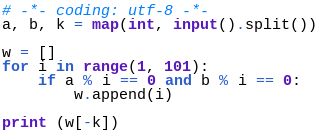Convert code to text. <code><loc_0><loc_0><loc_500><loc_500><_Python_># -*- coding: utf-8 -*-
a, b, k = map(int, input().split())

w = []
for i in range(1, 101):
    if a % i == 0 and b % i == 0:
        w.append(i)

print (w[-k])</code> 